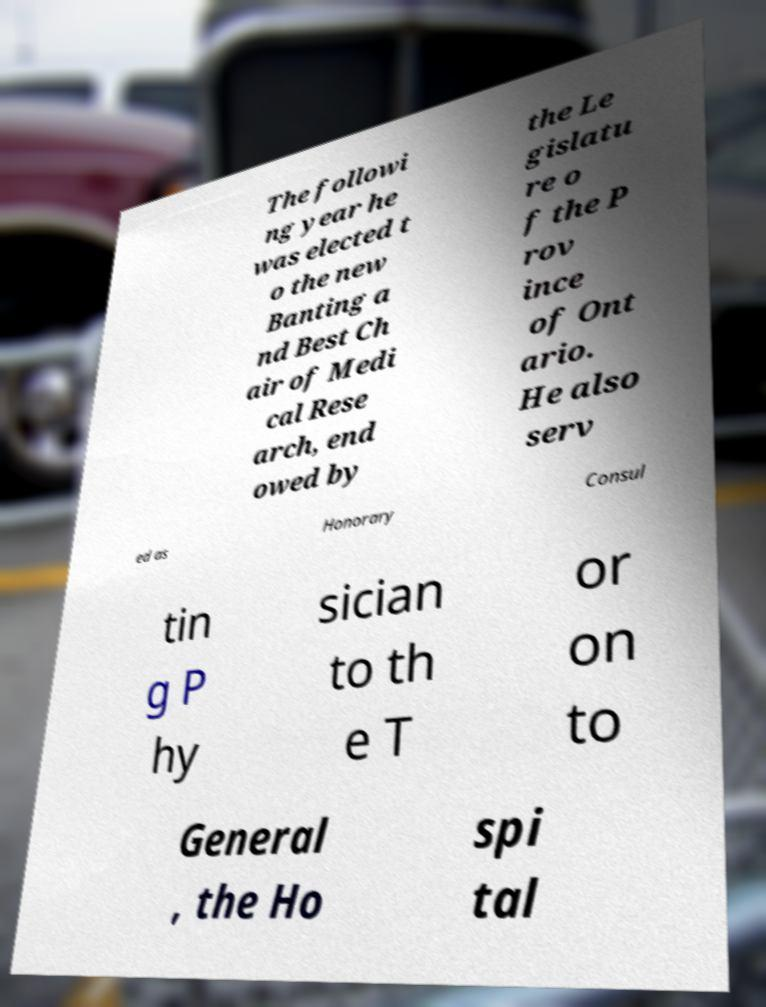Can you accurately transcribe the text from the provided image for me? The followi ng year he was elected t o the new Banting a nd Best Ch air of Medi cal Rese arch, end owed by the Le gislatu re o f the P rov ince of Ont ario. He also serv ed as Honorary Consul tin g P hy sician to th e T or on to General , the Ho spi tal 